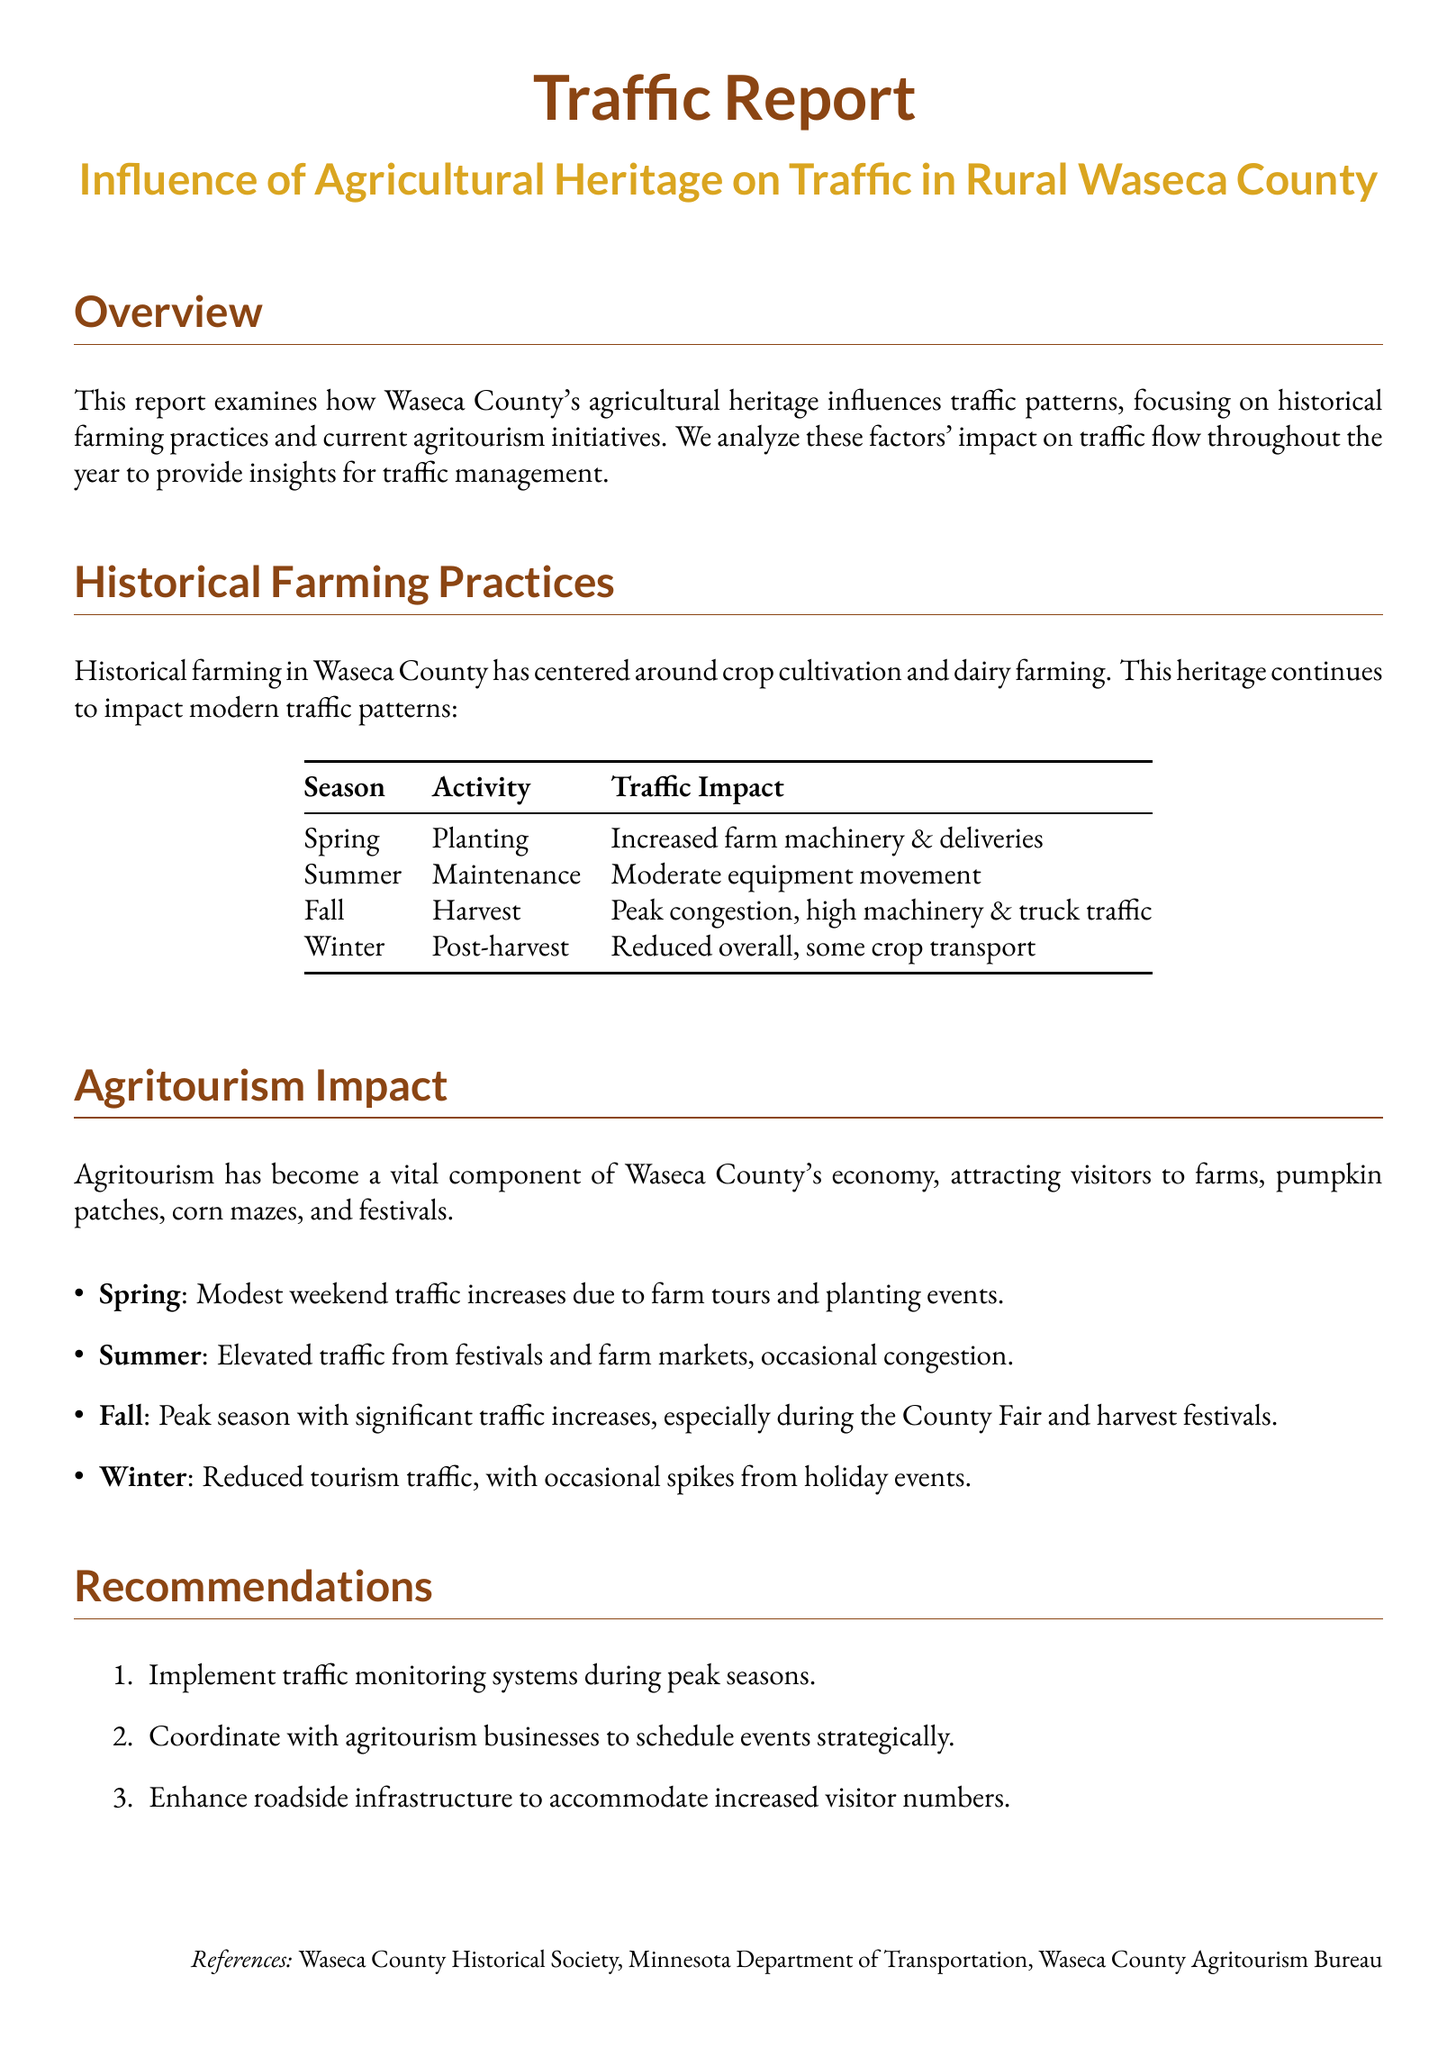What is the main focus of the report? The report focuses on the influence of agricultural heritage on traffic patterns in Waseca County, especially from historic farming practices and agritourism.
Answer: agricultural heritage Which season has peak congestion? The table indicates that fall has peak congestion due to harvest activities.
Answer: Fall How many recommendations are provided in the report? There are three recommendations listed in the recommendations section.
Answer: three What type of traffic increase occurs in spring due to agritourism? The report mentions a modest weekend traffic increase during spring for farm tours and planting events.
Answer: modest weekend traffic increase In what season is there reduced overall traffic? The document states that winter has reduced overall traffic after the harvest.
Answer: Winter What is a specific event that causes significant traffic increases in the fall? The County Fair is specifically mentioned as an event that causes traffic increases during the fall.
Answer: County Fair What are the two main historical farming practices identified? The report identifies crop cultivation and dairy farming as the two main historical practices.
Answer: crop cultivation and dairy farming What is suggested to accommodate increased visitor numbers? The report recommends enhancing roadside infrastructure as a solution for accommodating increased visitor numbers.
Answer: enhancing roadside infrastructure 